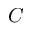<formula> <loc_0><loc_0><loc_500><loc_500>C</formula> 